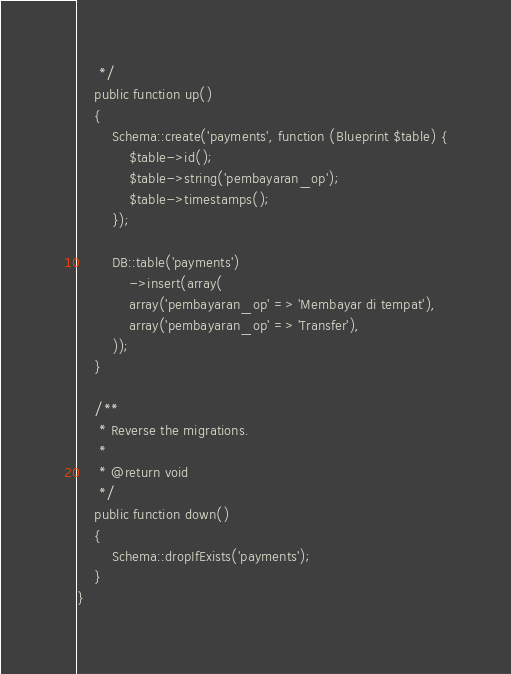<code> <loc_0><loc_0><loc_500><loc_500><_PHP_>     */
    public function up()
    {
        Schema::create('payments', function (Blueprint $table) {
            $table->id();
            $table->string('pembayaran_op');
            $table->timestamps();
        });

        DB::table('payments')
            ->insert(array(
            array('pembayaran_op' => 'Membayar di tempat'),
            array('pembayaran_op' => 'Transfer'),
        ));
    }

    /**
     * Reverse the migrations.
     *
     * @return void
     */
    public function down()
    {
        Schema::dropIfExists('payments');
    }
}
</code> 